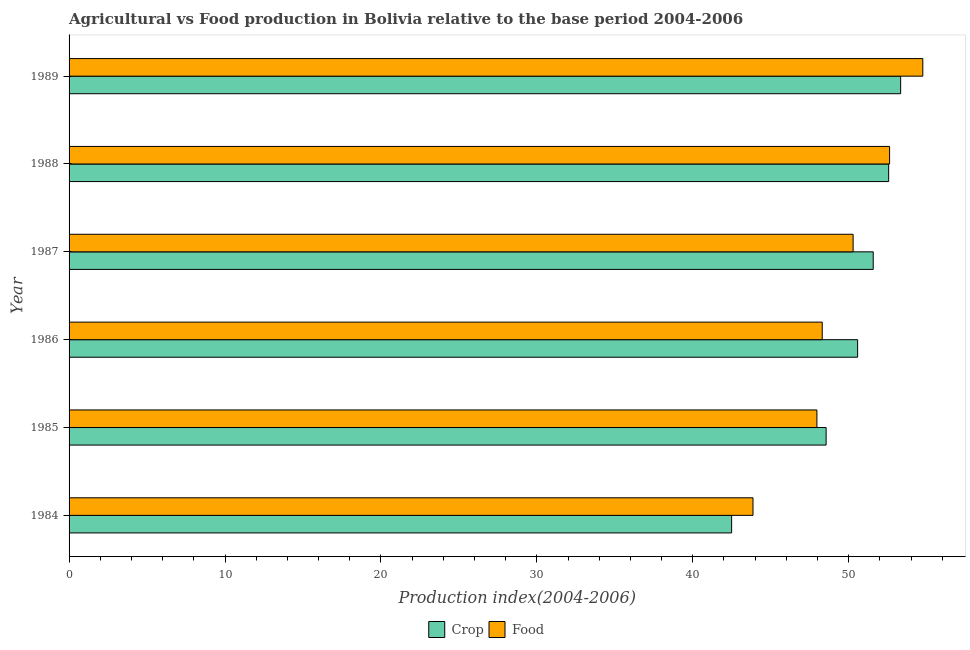How many groups of bars are there?
Ensure brevity in your answer.  6. Are the number of bars per tick equal to the number of legend labels?
Provide a short and direct response. Yes. Are the number of bars on each tick of the Y-axis equal?
Your response must be concise. Yes. What is the label of the 6th group of bars from the top?
Your answer should be compact. 1984. In how many cases, is the number of bars for a given year not equal to the number of legend labels?
Provide a short and direct response. 0. What is the crop production index in 1988?
Provide a short and direct response. 52.56. Across all years, what is the maximum crop production index?
Offer a very short reply. 53.33. Across all years, what is the minimum crop production index?
Give a very brief answer. 42.49. In which year was the food production index maximum?
Make the answer very short. 1989. In which year was the food production index minimum?
Ensure brevity in your answer.  1984. What is the total crop production index in the graph?
Make the answer very short. 299.07. What is the difference between the food production index in 1987 and that in 1989?
Keep it short and to the point. -4.47. What is the difference between the food production index in 1987 and the crop production index in 1988?
Give a very brief answer. -2.28. What is the average crop production index per year?
Make the answer very short. 49.84. In the year 1989, what is the difference between the food production index and crop production index?
Your response must be concise. 1.42. What is the ratio of the food production index in 1984 to that in 1986?
Your answer should be very brief. 0.91. What is the difference between the highest and the second highest crop production index?
Offer a very short reply. 0.77. What is the difference between the highest and the lowest crop production index?
Provide a short and direct response. 10.84. Is the sum of the food production index in 1984 and 1985 greater than the maximum crop production index across all years?
Your answer should be very brief. Yes. What does the 1st bar from the top in 1987 represents?
Offer a terse response. Food. What does the 2nd bar from the bottom in 1985 represents?
Provide a succinct answer. Food. How many years are there in the graph?
Provide a short and direct response. 6. What is the difference between two consecutive major ticks on the X-axis?
Your answer should be very brief. 10. Are the values on the major ticks of X-axis written in scientific E-notation?
Keep it short and to the point. No. Where does the legend appear in the graph?
Offer a terse response. Bottom center. What is the title of the graph?
Make the answer very short. Agricultural vs Food production in Bolivia relative to the base period 2004-2006. What is the label or title of the X-axis?
Offer a very short reply. Production index(2004-2006). What is the Production index(2004-2006) in Crop in 1984?
Give a very brief answer. 42.49. What is the Production index(2004-2006) of Food in 1984?
Your answer should be very brief. 43.86. What is the Production index(2004-2006) in Crop in 1985?
Offer a very short reply. 48.55. What is the Production index(2004-2006) of Food in 1985?
Ensure brevity in your answer.  47.96. What is the Production index(2004-2006) of Crop in 1986?
Your answer should be compact. 50.57. What is the Production index(2004-2006) in Food in 1986?
Provide a short and direct response. 48.3. What is the Production index(2004-2006) in Crop in 1987?
Ensure brevity in your answer.  51.57. What is the Production index(2004-2006) in Food in 1987?
Ensure brevity in your answer.  50.28. What is the Production index(2004-2006) of Crop in 1988?
Make the answer very short. 52.56. What is the Production index(2004-2006) of Food in 1988?
Keep it short and to the point. 52.62. What is the Production index(2004-2006) in Crop in 1989?
Offer a very short reply. 53.33. What is the Production index(2004-2006) of Food in 1989?
Make the answer very short. 54.75. Across all years, what is the maximum Production index(2004-2006) in Crop?
Keep it short and to the point. 53.33. Across all years, what is the maximum Production index(2004-2006) in Food?
Provide a succinct answer. 54.75. Across all years, what is the minimum Production index(2004-2006) in Crop?
Provide a short and direct response. 42.49. Across all years, what is the minimum Production index(2004-2006) of Food?
Make the answer very short. 43.86. What is the total Production index(2004-2006) of Crop in the graph?
Your answer should be compact. 299.07. What is the total Production index(2004-2006) of Food in the graph?
Give a very brief answer. 297.77. What is the difference between the Production index(2004-2006) in Crop in 1984 and that in 1985?
Ensure brevity in your answer.  -6.06. What is the difference between the Production index(2004-2006) in Food in 1984 and that in 1985?
Make the answer very short. -4.1. What is the difference between the Production index(2004-2006) of Crop in 1984 and that in 1986?
Provide a succinct answer. -8.08. What is the difference between the Production index(2004-2006) in Food in 1984 and that in 1986?
Provide a short and direct response. -4.44. What is the difference between the Production index(2004-2006) in Crop in 1984 and that in 1987?
Give a very brief answer. -9.08. What is the difference between the Production index(2004-2006) of Food in 1984 and that in 1987?
Provide a succinct answer. -6.42. What is the difference between the Production index(2004-2006) in Crop in 1984 and that in 1988?
Give a very brief answer. -10.07. What is the difference between the Production index(2004-2006) in Food in 1984 and that in 1988?
Your answer should be compact. -8.76. What is the difference between the Production index(2004-2006) in Crop in 1984 and that in 1989?
Offer a terse response. -10.84. What is the difference between the Production index(2004-2006) in Food in 1984 and that in 1989?
Your answer should be compact. -10.89. What is the difference between the Production index(2004-2006) in Crop in 1985 and that in 1986?
Offer a very short reply. -2.02. What is the difference between the Production index(2004-2006) in Food in 1985 and that in 1986?
Provide a succinct answer. -0.34. What is the difference between the Production index(2004-2006) in Crop in 1985 and that in 1987?
Your answer should be very brief. -3.02. What is the difference between the Production index(2004-2006) in Food in 1985 and that in 1987?
Your response must be concise. -2.32. What is the difference between the Production index(2004-2006) of Crop in 1985 and that in 1988?
Offer a very short reply. -4.01. What is the difference between the Production index(2004-2006) in Food in 1985 and that in 1988?
Offer a very short reply. -4.66. What is the difference between the Production index(2004-2006) in Crop in 1985 and that in 1989?
Make the answer very short. -4.78. What is the difference between the Production index(2004-2006) of Food in 1985 and that in 1989?
Give a very brief answer. -6.79. What is the difference between the Production index(2004-2006) in Food in 1986 and that in 1987?
Keep it short and to the point. -1.98. What is the difference between the Production index(2004-2006) in Crop in 1986 and that in 1988?
Your answer should be very brief. -1.99. What is the difference between the Production index(2004-2006) in Food in 1986 and that in 1988?
Your response must be concise. -4.32. What is the difference between the Production index(2004-2006) of Crop in 1986 and that in 1989?
Offer a terse response. -2.76. What is the difference between the Production index(2004-2006) in Food in 1986 and that in 1989?
Your answer should be compact. -6.45. What is the difference between the Production index(2004-2006) of Crop in 1987 and that in 1988?
Your answer should be very brief. -0.99. What is the difference between the Production index(2004-2006) of Food in 1987 and that in 1988?
Your response must be concise. -2.34. What is the difference between the Production index(2004-2006) in Crop in 1987 and that in 1989?
Your response must be concise. -1.76. What is the difference between the Production index(2004-2006) in Food in 1987 and that in 1989?
Your answer should be very brief. -4.47. What is the difference between the Production index(2004-2006) of Crop in 1988 and that in 1989?
Your answer should be compact. -0.77. What is the difference between the Production index(2004-2006) in Food in 1988 and that in 1989?
Ensure brevity in your answer.  -2.13. What is the difference between the Production index(2004-2006) in Crop in 1984 and the Production index(2004-2006) in Food in 1985?
Make the answer very short. -5.47. What is the difference between the Production index(2004-2006) in Crop in 1984 and the Production index(2004-2006) in Food in 1986?
Ensure brevity in your answer.  -5.81. What is the difference between the Production index(2004-2006) of Crop in 1984 and the Production index(2004-2006) of Food in 1987?
Give a very brief answer. -7.79. What is the difference between the Production index(2004-2006) in Crop in 1984 and the Production index(2004-2006) in Food in 1988?
Provide a succinct answer. -10.13. What is the difference between the Production index(2004-2006) of Crop in 1984 and the Production index(2004-2006) of Food in 1989?
Your answer should be compact. -12.26. What is the difference between the Production index(2004-2006) of Crop in 1985 and the Production index(2004-2006) of Food in 1987?
Make the answer very short. -1.73. What is the difference between the Production index(2004-2006) of Crop in 1985 and the Production index(2004-2006) of Food in 1988?
Make the answer very short. -4.07. What is the difference between the Production index(2004-2006) in Crop in 1986 and the Production index(2004-2006) in Food in 1987?
Provide a short and direct response. 0.29. What is the difference between the Production index(2004-2006) of Crop in 1986 and the Production index(2004-2006) of Food in 1988?
Provide a short and direct response. -2.05. What is the difference between the Production index(2004-2006) of Crop in 1986 and the Production index(2004-2006) of Food in 1989?
Your answer should be compact. -4.18. What is the difference between the Production index(2004-2006) in Crop in 1987 and the Production index(2004-2006) in Food in 1988?
Offer a terse response. -1.05. What is the difference between the Production index(2004-2006) in Crop in 1987 and the Production index(2004-2006) in Food in 1989?
Provide a short and direct response. -3.18. What is the difference between the Production index(2004-2006) of Crop in 1988 and the Production index(2004-2006) of Food in 1989?
Ensure brevity in your answer.  -2.19. What is the average Production index(2004-2006) in Crop per year?
Ensure brevity in your answer.  49.84. What is the average Production index(2004-2006) in Food per year?
Offer a very short reply. 49.63. In the year 1984, what is the difference between the Production index(2004-2006) of Crop and Production index(2004-2006) of Food?
Provide a succinct answer. -1.37. In the year 1985, what is the difference between the Production index(2004-2006) in Crop and Production index(2004-2006) in Food?
Offer a terse response. 0.59. In the year 1986, what is the difference between the Production index(2004-2006) of Crop and Production index(2004-2006) of Food?
Offer a terse response. 2.27. In the year 1987, what is the difference between the Production index(2004-2006) of Crop and Production index(2004-2006) of Food?
Offer a very short reply. 1.29. In the year 1988, what is the difference between the Production index(2004-2006) of Crop and Production index(2004-2006) of Food?
Offer a terse response. -0.06. In the year 1989, what is the difference between the Production index(2004-2006) of Crop and Production index(2004-2006) of Food?
Offer a very short reply. -1.42. What is the ratio of the Production index(2004-2006) of Crop in 1984 to that in 1985?
Make the answer very short. 0.88. What is the ratio of the Production index(2004-2006) of Food in 1984 to that in 1985?
Make the answer very short. 0.91. What is the ratio of the Production index(2004-2006) in Crop in 1984 to that in 1986?
Your answer should be very brief. 0.84. What is the ratio of the Production index(2004-2006) of Food in 1984 to that in 1986?
Offer a terse response. 0.91. What is the ratio of the Production index(2004-2006) in Crop in 1984 to that in 1987?
Your answer should be compact. 0.82. What is the ratio of the Production index(2004-2006) in Food in 1984 to that in 1987?
Provide a succinct answer. 0.87. What is the ratio of the Production index(2004-2006) of Crop in 1984 to that in 1988?
Your answer should be compact. 0.81. What is the ratio of the Production index(2004-2006) in Food in 1984 to that in 1988?
Make the answer very short. 0.83. What is the ratio of the Production index(2004-2006) in Crop in 1984 to that in 1989?
Provide a short and direct response. 0.8. What is the ratio of the Production index(2004-2006) in Food in 1984 to that in 1989?
Provide a short and direct response. 0.8. What is the ratio of the Production index(2004-2006) of Crop in 1985 to that in 1986?
Offer a very short reply. 0.96. What is the ratio of the Production index(2004-2006) in Food in 1985 to that in 1986?
Make the answer very short. 0.99. What is the ratio of the Production index(2004-2006) in Crop in 1985 to that in 1987?
Your answer should be very brief. 0.94. What is the ratio of the Production index(2004-2006) in Food in 1985 to that in 1987?
Provide a succinct answer. 0.95. What is the ratio of the Production index(2004-2006) of Crop in 1985 to that in 1988?
Ensure brevity in your answer.  0.92. What is the ratio of the Production index(2004-2006) of Food in 1985 to that in 1988?
Your response must be concise. 0.91. What is the ratio of the Production index(2004-2006) in Crop in 1985 to that in 1989?
Offer a very short reply. 0.91. What is the ratio of the Production index(2004-2006) of Food in 1985 to that in 1989?
Give a very brief answer. 0.88. What is the ratio of the Production index(2004-2006) of Crop in 1986 to that in 1987?
Provide a short and direct response. 0.98. What is the ratio of the Production index(2004-2006) in Food in 1986 to that in 1987?
Your response must be concise. 0.96. What is the ratio of the Production index(2004-2006) in Crop in 1986 to that in 1988?
Make the answer very short. 0.96. What is the ratio of the Production index(2004-2006) of Food in 1986 to that in 1988?
Offer a very short reply. 0.92. What is the ratio of the Production index(2004-2006) of Crop in 1986 to that in 1989?
Offer a very short reply. 0.95. What is the ratio of the Production index(2004-2006) of Food in 1986 to that in 1989?
Provide a succinct answer. 0.88. What is the ratio of the Production index(2004-2006) in Crop in 1987 to that in 1988?
Offer a terse response. 0.98. What is the ratio of the Production index(2004-2006) in Food in 1987 to that in 1988?
Offer a terse response. 0.96. What is the ratio of the Production index(2004-2006) in Crop in 1987 to that in 1989?
Offer a very short reply. 0.97. What is the ratio of the Production index(2004-2006) in Food in 1987 to that in 1989?
Offer a terse response. 0.92. What is the ratio of the Production index(2004-2006) of Crop in 1988 to that in 1989?
Keep it short and to the point. 0.99. What is the ratio of the Production index(2004-2006) in Food in 1988 to that in 1989?
Ensure brevity in your answer.  0.96. What is the difference between the highest and the second highest Production index(2004-2006) in Crop?
Your response must be concise. 0.77. What is the difference between the highest and the second highest Production index(2004-2006) of Food?
Your response must be concise. 2.13. What is the difference between the highest and the lowest Production index(2004-2006) in Crop?
Ensure brevity in your answer.  10.84. What is the difference between the highest and the lowest Production index(2004-2006) in Food?
Offer a very short reply. 10.89. 